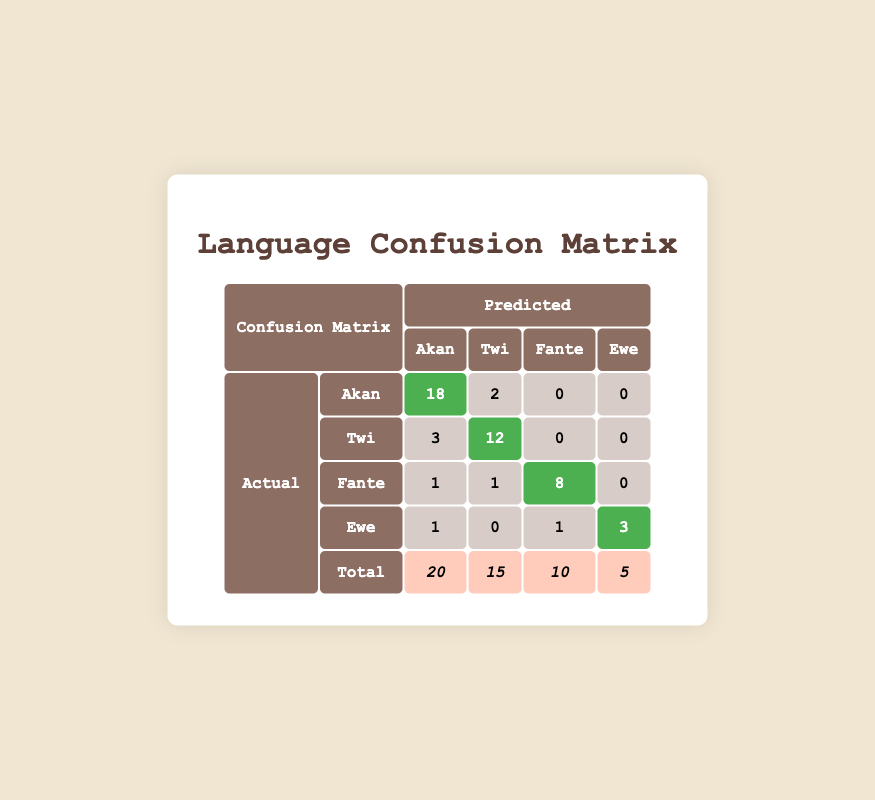What is the number of actual documents for the Twi dialect? The table states that under the "actual" column for "Twi," the value is 15, which indicates the number of actual documents collected for the Twi dialect.
Answer: 15 What are the instances where Akan was confused with other dialects? Looking at the row for Akan, the Schenquencer shows two instances where Akan was confused with Twi, with values of 18 predicted correctly for Akan and 2 mistakenly for Twi. Other dialects like Fante and Ewe show no confusion in this case, indicated by values of 0.
Answer: 2 (Akan confused with Twi) How many total instances were recorded for the Ewe dialect? The total instances for Ewe can be found in the last row under the total column, which shows a value of 5. Additionally, the count in the Ewe row for actual documents is shown as 5.
Answer: 5 What is the accuracy of predicting Twi documents correctly? The accuracy can be calculated using the formula: (correct predictions for Twi) / (actual Twi documents) = 12 / 15. Therefore, accuracy = (12/15) * 100 = 80%.
Answer: 80% Is there any confusion when predicting the Fante dialect? To find this out, we can refer to the Fante row. We see that there are 1 instances of confusion with Akan and 1 with Twi, while 8 are predicted correctly, indicating that there was confusion present. Therefore, the answer to the question is yes.
Answer: Yes What is the total number of documents collected across all dialects? By summing the totals in the final row, we find that 20 (Akan) + 15 (Twi) + 10 (Fante) + 5 (Ewe) = 50. This gives us the total number of documents collected for all dialects.
Answer: 50 How many instances of confusion occur when predicting Ewe dialect? The Ewe row shows 1 confusion with Akan, no confusion with Twi, 1 with Fante, and 3 predicted correctly, so the total confusion instances is 1 + 0 + 1 = 2.
Answer: 2 What is the highest number of correct predictions for any dialect? Checking all the predicted values, Akan shows 18, Twi shows 12, Fante shows 8, and Ewe shows 3. The highest number of correct predictions is 18 for Akan.
Answer: 18 How many instances were incorrectly predicted for Fante? In the Fante row, we see that there are 1 instances confused with Akan, 1 with Twi, and 0 with Ewe, leading to a total of 2 incorrect predictions for Fante.
Answer: 2 What is the total number of dialects represented in the actual data? The 'actual' section lists four dialects: Akan, Twi, Fante, and Ewe. Therefore, the number of dialects represented in the dataset is four.
Answer: 4 